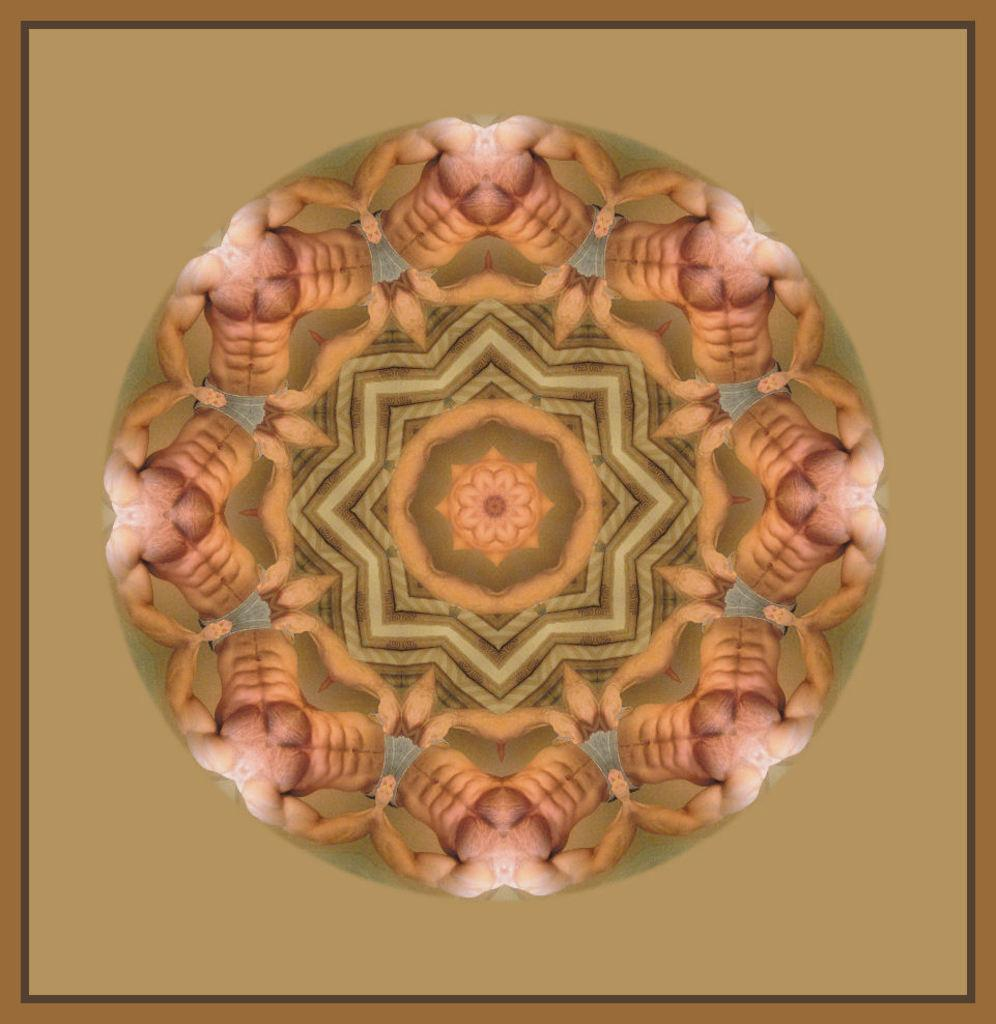What is the main subject of the image? The main subject of the image is an edited picture of human bodies. What can be observed in the image besides the human bodies? There are designs present in the image. What type of tent can be seen in the image? There is no tent present in the image; it features an edited picture of human bodies with designs. What decision can be seen being made in the image? There is no decision-making process depicted in the image; it is an edited picture of human bodies with designs. 